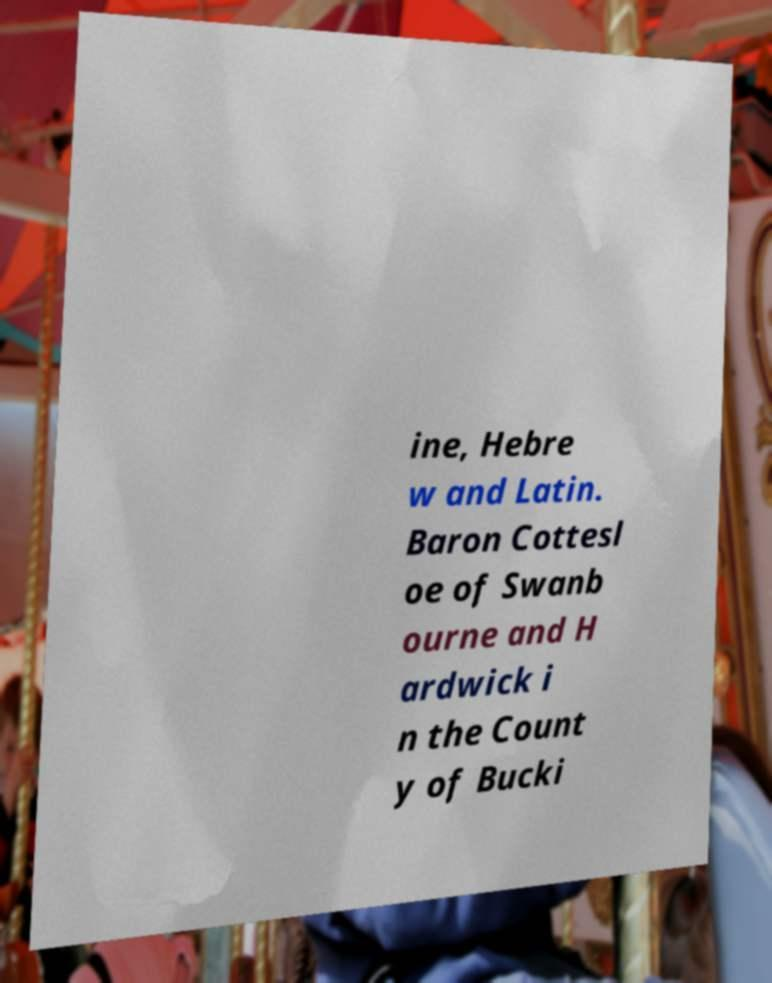Could you assist in decoding the text presented in this image and type it out clearly? ine, Hebre w and Latin. Baron Cottesl oe of Swanb ourne and H ardwick i n the Count y of Bucki 